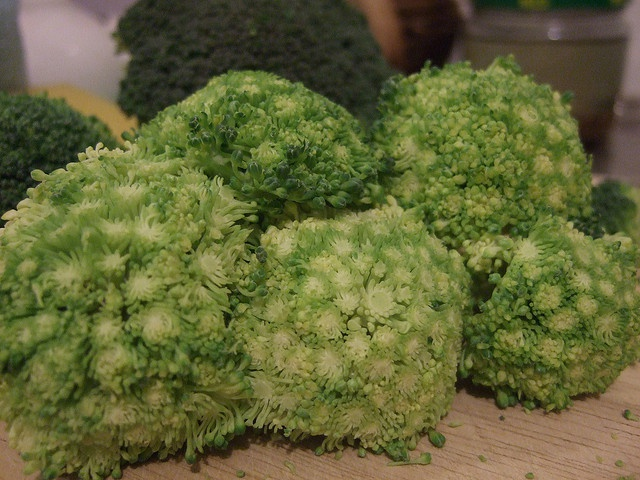Describe the objects in this image and their specific colors. I can see a broccoli in darkgreen, gray, black, and olive tones in this image. 